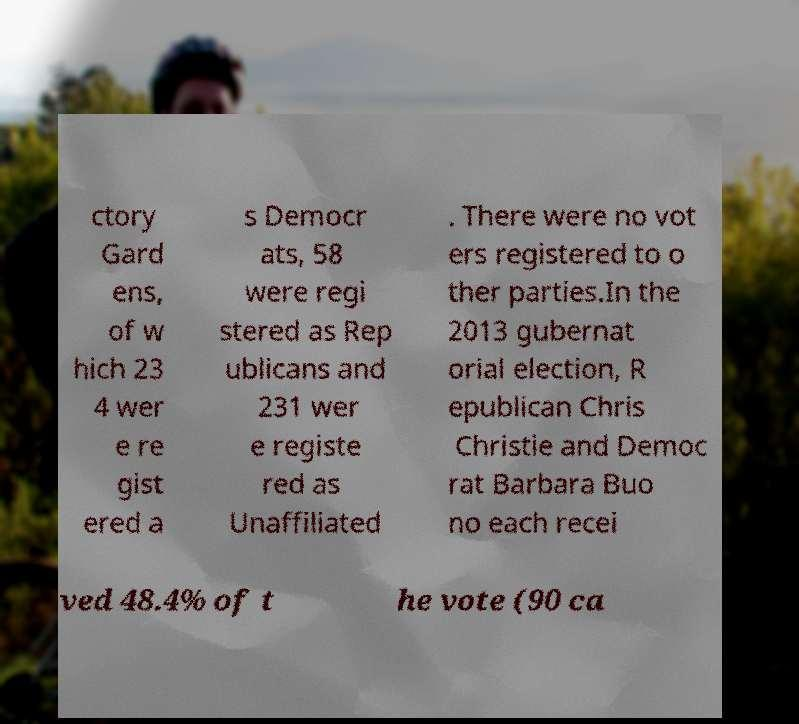Could you assist in decoding the text presented in this image and type it out clearly? ctory Gard ens, of w hich 23 4 wer e re gist ered a s Democr ats, 58 were regi stered as Rep ublicans and 231 wer e registe red as Unaffiliated . There were no vot ers registered to o ther parties.In the 2013 gubernat orial election, R epublican Chris Christie and Democ rat Barbara Buo no each recei ved 48.4% of t he vote (90 ca 